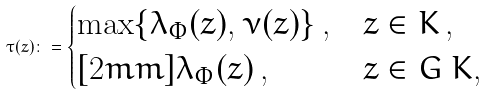<formula> <loc_0><loc_0><loc_500><loc_500>\tau ( z ) \colon = \begin{cases} \max \{ \lambda _ { \Phi } ( z ) , \nu ( z ) \} \, , & z \in K \, , \\ [ 2 m m ] \lambda _ { \Phi } ( z ) \, , & z \in G \ K , \end{cases}</formula> 